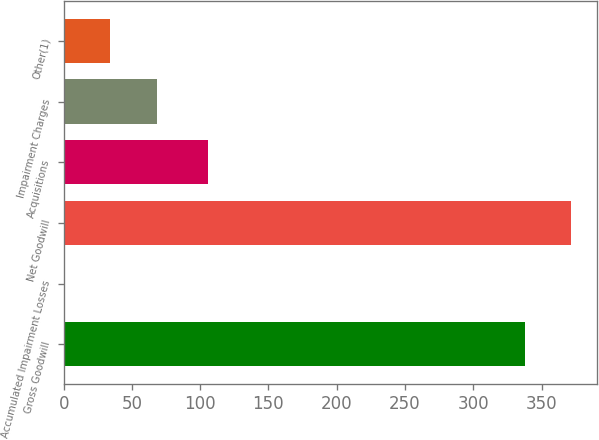Convert chart to OTSL. <chart><loc_0><loc_0><loc_500><loc_500><bar_chart><fcel>Gross Goodwill<fcel>Accumulated Impairment Losses<fcel>Net Goodwill<fcel>Acquisitions<fcel>Impairment Charges<fcel>Other(1)<nl><fcel>338<fcel>0.57<fcel>371.74<fcel>106<fcel>68.05<fcel>34.31<nl></chart> 